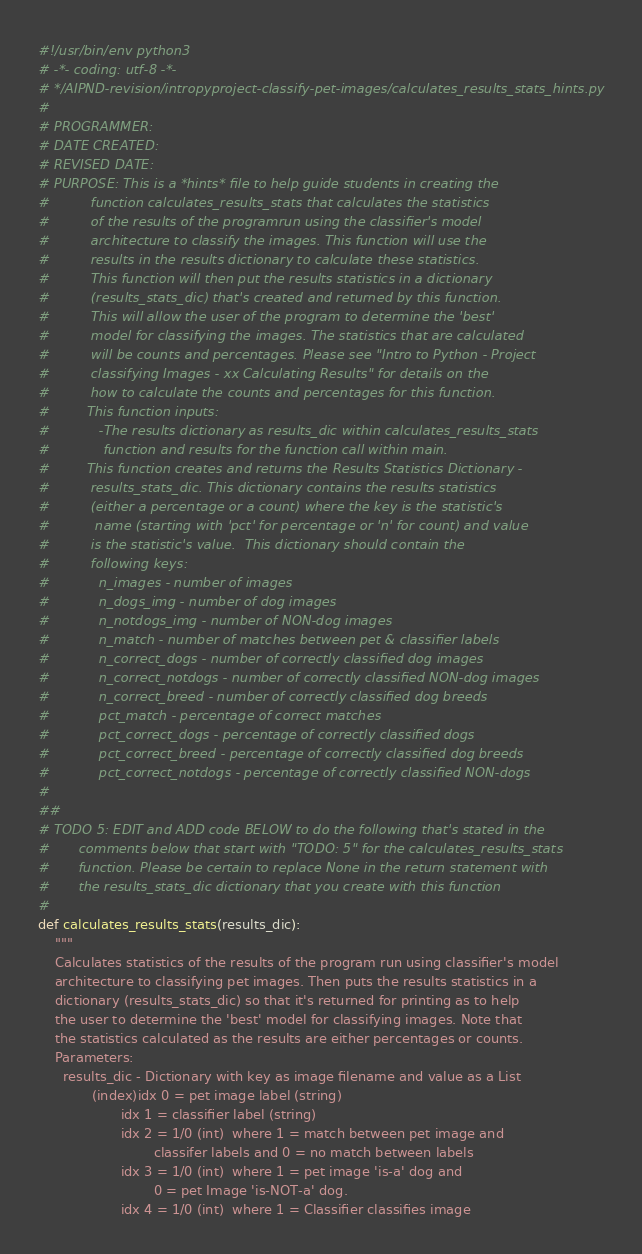<code> <loc_0><loc_0><loc_500><loc_500><_Python_>#!/usr/bin/env python3
# -*- coding: utf-8 -*-
# */AIPND-revision/intropyproject-classify-pet-images/calculates_results_stats_hints.py
#
# PROGRAMMER:
# DATE CREATED:
# REVISED DATE:
# PURPOSE: This is a *hints* file to help guide students in creating the
#          function calculates_results_stats that calculates the statistics
#          of the results of the programrun using the classifier's model
#          architecture to classify the images. This function will use the
#          results in the results dictionary to calculate these statistics.
#          This function will then put the results statistics in a dictionary
#          (results_stats_dic) that's created and returned by this function.
#          This will allow the user of the program to determine the 'best'
#          model for classifying the images. The statistics that are calculated
#          will be counts and percentages. Please see "Intro to Python - Project
#          classifying Images - xx Calculating Results" for details on the
#          how to calculate the counts and percentages for this function.
#         This function inputs:
#            -The results dictionary as results_dic within calculates_results_stats
#             function and results for the function call within main.
#         This function creates and returns the Results Statistics Dictionary -
#          results_stats_dic. This dictionary contains the results statistics
#          (either a percentage or a count) where the key is the statistic's
#           name (starting with 'pct' for percentage or 'n' for count) and value
#          is the statistic's value.  This dictionary should contain the
#          following keys:
#            n_images - number of images
#            n_dogs_img - number of dog images
#            n_notdogs_img - number of NON-dog images
#            n_match - number of matches between pet & classifier labels
#            n_correct_dogs - number of correctly classified dog images
#            n_correct_notdogs - number of correctly classified NON-dog images
#            n_correct_breed - number of correctly classified dog breeds
#            pct_match - percentage of correct matches
#            pct_correct_dogs - percentage of correctly classified dogs
#            pct_correct_breed - percentage of correctly classified dog breeds
#            pct_correct_notdogs - percentage of correctly classified NON-dogs
#
##
# TODO 5: EDIT and ADD code BELOW to do the following that's stated in the
#       comments below that start with "TODO: 5" for the calculates_results_stats
#       function. Please be certain to replace None in the return statement with
#       the results_stats_dic dictionary that you create with this function
#
def calculates_results_stats(results_dic):
    """
    Calculates statistics of the results of the program run using classifier's model
    architecture to classifying pet images. Then puts the results statistics in a
    dictionary (results_stats_dic) so that it's returned for printing as to help
    the user to determine the 'best' model for classifying images. Note that
    the statistics calculated as the results are either percentages or counts.
    Parameters:
      results_dic - Dictionary with key as image filename and value as a List
             (index)idx 0 = pet image label (string)
                    idx 1 = classifier label (string)
                    idx 2 = 1/0 (int)  where 1 = match between pet image and
                            classifer labels and 0 = no match between labels
                    idx 3 = 1/0 (int)  where 1 = pet image 'is-a' dog and
                            0 = pet Image 'is-NOT-a' dog.
                    idx 4 = 1/0 (int)  where 1 = Classifier classifies image</code> 